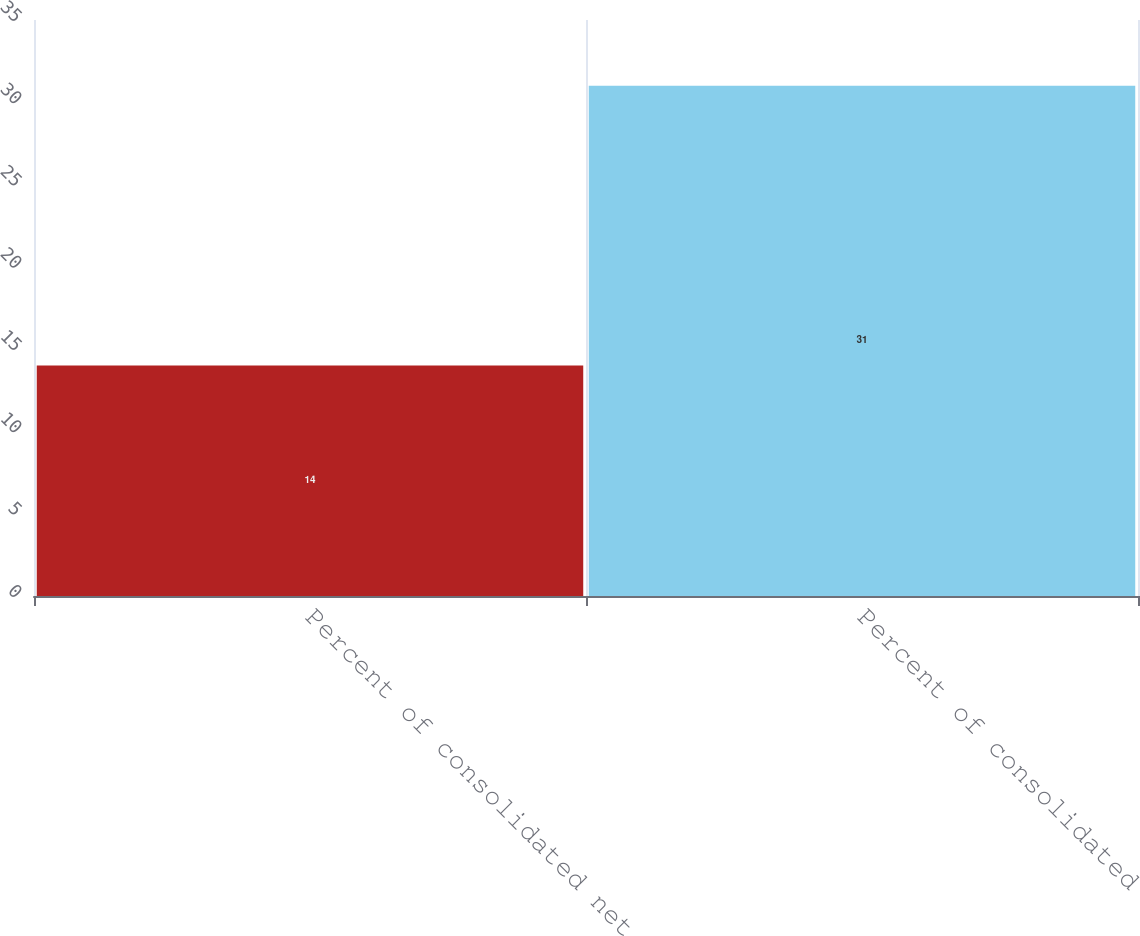<chart> <loc_0><loc_0><loc_500><loc_500><bar_chart><fcel>Percent of consolidated net<fcel>Percent of consolidated<nl><fcel>14<fcel>31<nl></chart> 